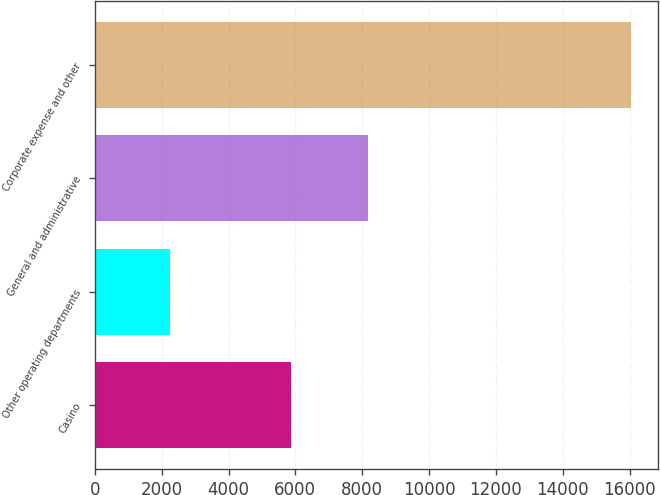<chart> <loc_0><loc_0><loc_500><loc_500><bar_chart><fcel>Casino<fcel>Other operating departments<fcel>General and administrative<fcel>Corporate expense and other<nl><fcel>5879<fcel>2241<fcel>8176<fcel>16036<nl></chart> 